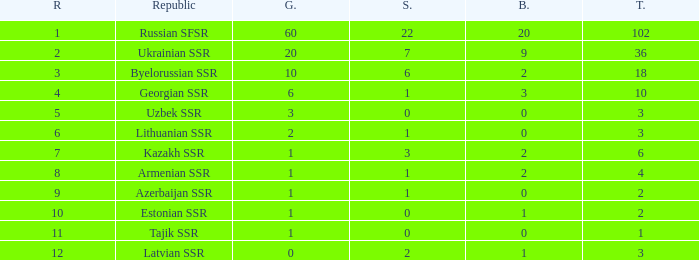What is the sum of bronzes for teams with more than 2 gold, ranked under 3, and less than 22 silver? 9.0. 